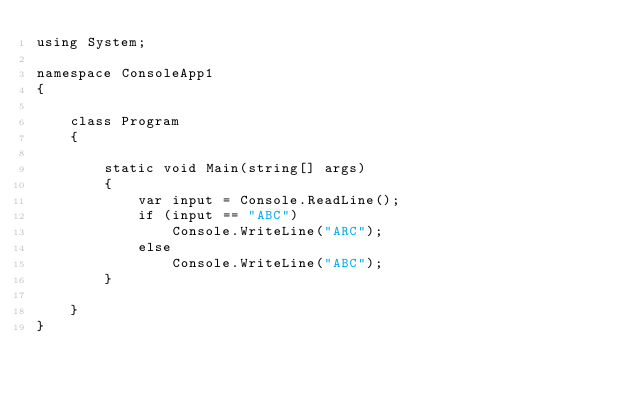Convert code to text. <code><loc_0><loc_0><loc_500><loc_500><_C#_>using System;

namespace ConsoleApp1
{

    class Program
    {

        static void Main(string[] args)
        {
            var input = Console.ReadLine();
            if (input == "ABC")
                Console.WriteLine("ARC");
            else
                Console.WriteLine("ABC");
        }

    }
}

</code> 